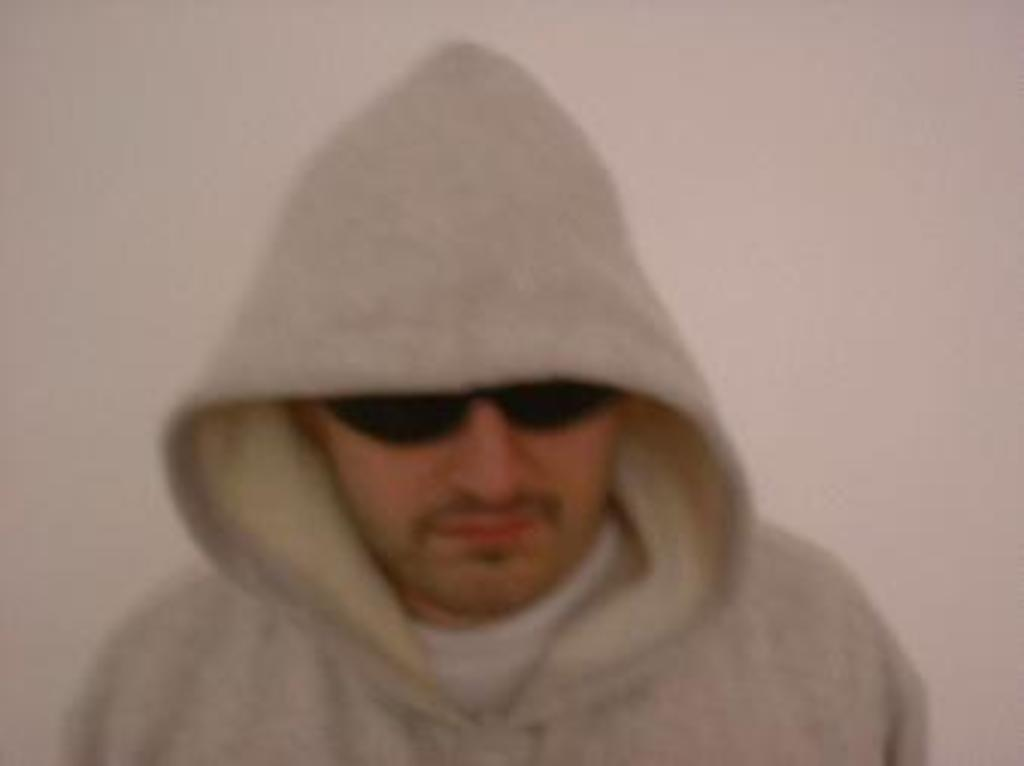Who is present in the image? There is a man in the image. What is the man wearing that is noticeable? The man is wearing black color glasses. What can be seen behind the man in the image? There is a plain wall in the background of the image. What type of kiss is the man giving in the image? There is no kiss present in the image; it only features a man wearing black color glasses in front of a plain wall. 